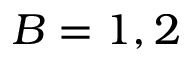Convert formula to latex. <formula><loc_0><loc_0><loc_500><loc_500>B = 1 , 2</formula> 